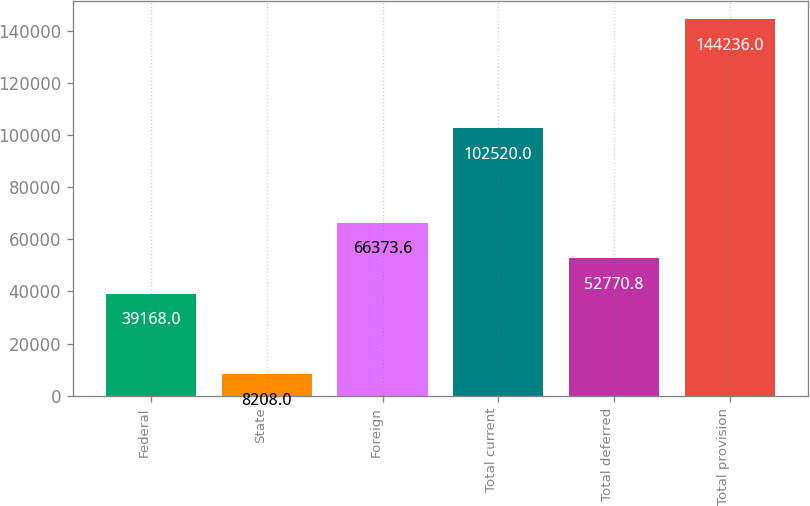Convert chart to OTSL. <chart><loc_0><loc_0><loc_500><loc_500><bar_chart><fcel>Federal<fcel>State<fcel>Foreign<fcel>Total current<fcel>Total deferred<fcel>Total provision<nl><fcel>39168<fcel>8208<fcel>66373.6<fcel>102520<fcel>52770.8<fcel>144236<nl></chart> 